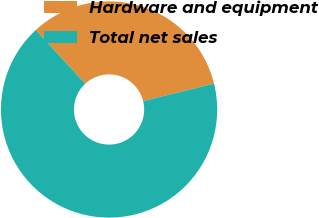<chart> <loc_0><loc_0><loc_500><loc_500><pie_chart><fcel>Hardware and equipment<fcel>Total net sales<nl><fcel>33.01%<fcel>66.99%<nl></chart> 